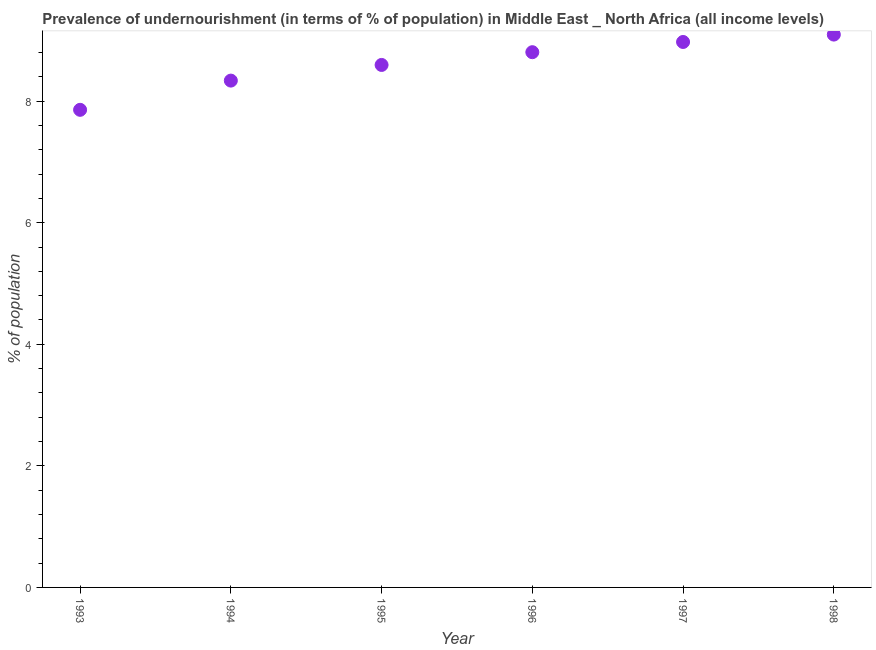What is the percentage of undernourished population in 1994?
Your answer should be very brief. 8.34. Across all years, what is the maximum percentage of undernourished population?
Make the answer very short. 9.09. Across all years, what is the minimum percentage of undernourished population?
Ensure brevity in your answer.  7.86. In which year was the percentage of undernourished population maximum?
Offer a very short reply. 1998. What is the sum of the percentage of undernourished population?
Offer a very short reply. 51.66. What is the difference between the percentage of undernourished population in 1993 and 1994?
Offer a terse response. -0.48. What is the average percentage of undernourished population per year?
Give a very brief answer. 8.61. What is the median percentage of undernourished population?
Give a very brief answer. 8.7. In how many years, is the percentage of undernourished population greater than 2 %?
Your answer should be compact. 6. What is the ratio of the percentage of undernourished population in 1995 to that in 1997?
Your answer should be compact. 0.96. Is the difference between the percentage of undernourished population in 1994 and 1996 greater than the difference between any two years?
Provide a short and direct response. No. What is the difference between the highest and the second highest percentage of undernourished population?
Keep it short and to the point. 0.12. What is the difference between the highest and the lowest percentage of undernourished population?
Your response must be concise. 1.24. In how many years, is the percentage of undernourished population greater than the average percentage of undernourished population taken over all years?
Your answer should be compact. 3. Does the percentage of undernourished population monotonically increase over the years?
Keep it short and to the point. Yes. How many dotlines are there?
Keep it short and to the point. 1. How many years are there in the graph?
Give a very brief answer. 6. Does the graph contain any zero values?
Your answer should be very brief. No. What is the title of the graph?
Offer a terse response. Prevalence of undernourishment (in terms of % of population) in Middle East _ North Africa (all income levels). What is the label or title of the Y-axis?
Provide a short and direct response. % of population. What is the % of population in 1993?
Ensure brevity in your answer.  7.86. What is the % of population in 1994?
Your answer should be compact. 8.34. What is the % of population in 1995?
Keep it short and to the point. 8.6. What is the % of population in 1996?
Offer a very short reply. 8.8. What is the % of population in 1997?
Offer a terse response. 8.97. What is the % of population in 1998?
Your answer should be compact. 9.09. What is the difference between the % of population in 1993 and 1994?
Keep it short and to the point. -0.48. What is the difference between the % of population in 1993 and 1995?
Your answer should be compact. -0.74. What is the difference between the % of population in 1993 and 1996?
Ensure brevity in your answer.  -0.95. What is the difference between the % of population in 1993 and 1997?
Your answer should be very brief. -1.12. What is the difference between the % of population in 1993 and 1998?
Keep it short and to the point. -1.24. What is the difference between the % of population in 1994 and 1995?
Provide a short and direct response. -0.26. What is the difference between the % of population in 1994 and 1996?
Your answer should be very brief. -0.47. What is the difference between the % of population in 1994 and 1997?
Offer a terse response. -0.64. What is the difference between the % of population in 1994 and 1998?
Your answer should be very brief. -0.76. What is the difference between the % of population in 1995 and 1996?
Provide a succinct answer. -0.21. What is the difference between the % of population in 1995 and 1997?
Provide a succinct answer. -0.38. What is the difference between the % of population in 1995 and 1998?
Make the answer very short. -0.5. What is the difference between the % of population in 1996 and 1997?
Your answer should be very brief. -0.17. What is the difference between the % of population in 1996 and 1998?
Make the answer very short. -0.29. What is the difference between the % of population in 1997 and 1998?
Your answer should be very brief. -0.12. What is the ratio of the % of population in 1993 to that in 1994?
Give a very brief answer. 0.94. What is the ratio of the % of population in 1993 to that in 1995?
Offer a very short reply. 0.91. What is the ratio of the % of population in 1993 to that in 1996?
Offer a terse response. 0.89. What is the ratio of the % of population in 1993 to that in 1997?
Your answer should be compact. 0.88. What is the ratio of the % of population in 1993 to that in 1998?
Make the answer very short. 0.86. What is the ratio of the % of population in 1994 to that in 1995?
Offer a terse response. 0.97. What is the ratio of the % of population in 1994 to that in 1996?
Make the answer very short. 0.95. What is the ratio of the % of population in 1994 to that in 1997?
Ensure brevity in your answer.  0.93. What is the ratio of the % of population in 1994 to that in 1998?
Give a very brief answer. 0.92. What is the ratio of the % of population in 1995 to that in 1997?
Ensure brevity in your answer.  0.96. What is the ratio of the % of population in 1995 to that in 1998?
Keep it short and to the point. 0.94. What is the ratio of the % of population in 1996 to that in 1997?
Offer a terse response. 0.98. What is the ratio of the % of population in 1996 to that in 1998?
Offer a terse response. 0.97. What is the ratio of the % of population in 1997 to that in 1998?
Offer a very short reply. 0.99. 